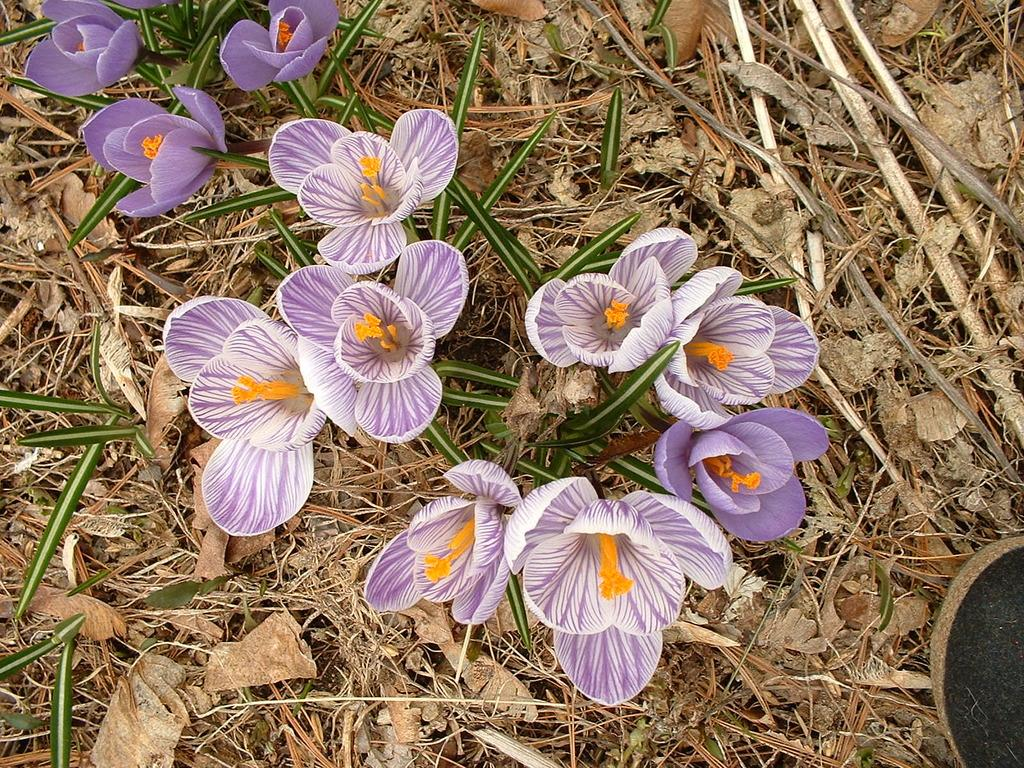What type of vegetation can be seen in the image? There are flowers, plants, and leaves present in the image. What else can be seen in the image besides vegetation? Grass is visible in the image. Where is the nest located in the image? There is no nest present in the image. What type of bait is being used to catch fish in the image? There is no fishing or bait present in the image. 